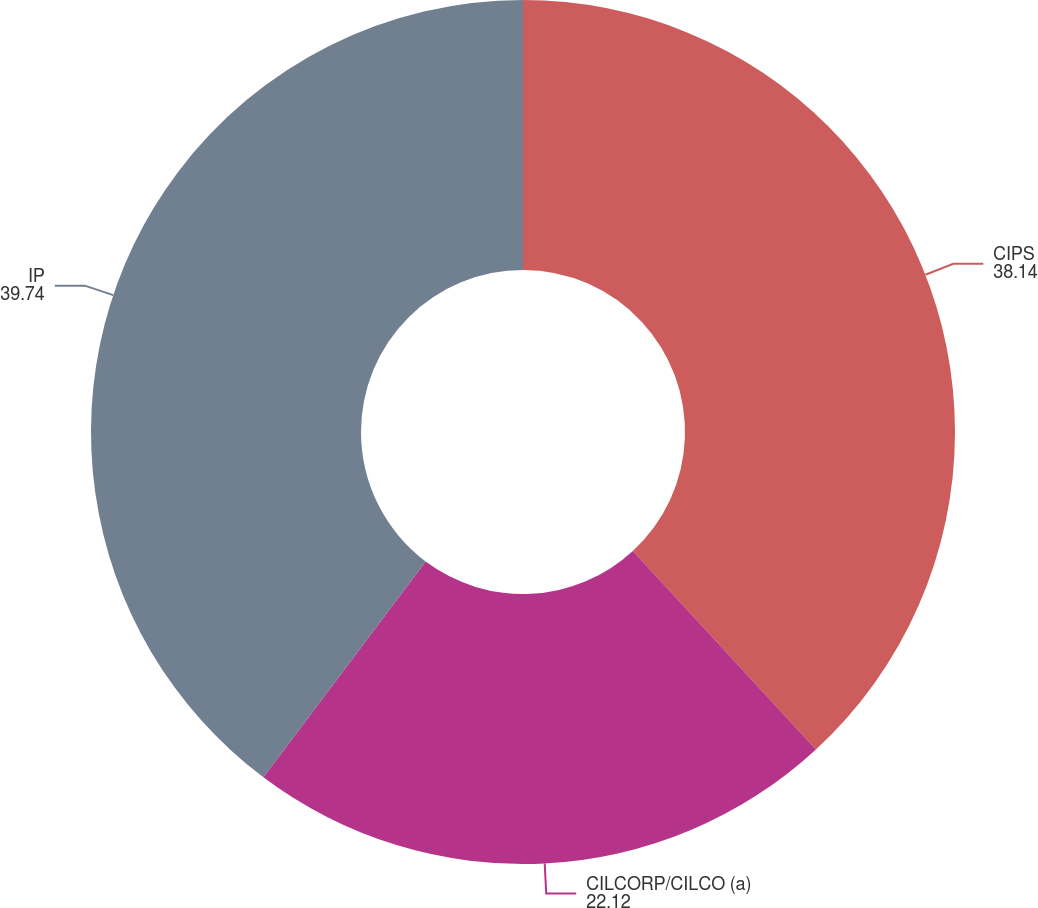Convert chart to OTSL. <chart><loc_0><loc_0><loc_500><loc_500><pie_chart><fcel>CIPS<fcel>CILCORP/CILCO (a)<fcel>IP<nl><fcel>38.14%<fcel>22.12%<fcel>39.74%<nl></chart> 